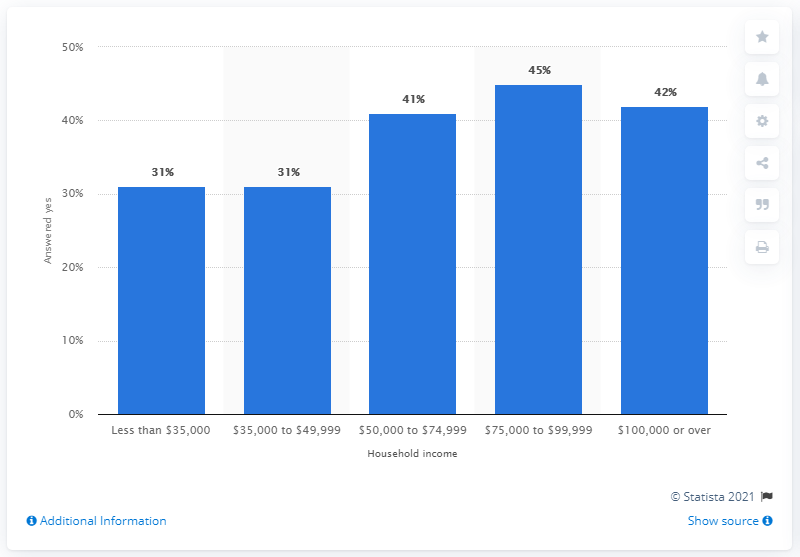What percentage of respondents with a household income between 35,000 and 49,999 U.S. dollars said they follow Major League Baseball? According to the bar chart, 31% of the respondents with a household income ranging from $35,000 to $49,999 stated that they follow Major League Baseball. This data point is part of a broader survey that explores the correlation between the interest in Major League Baseball and varying household income levels. 